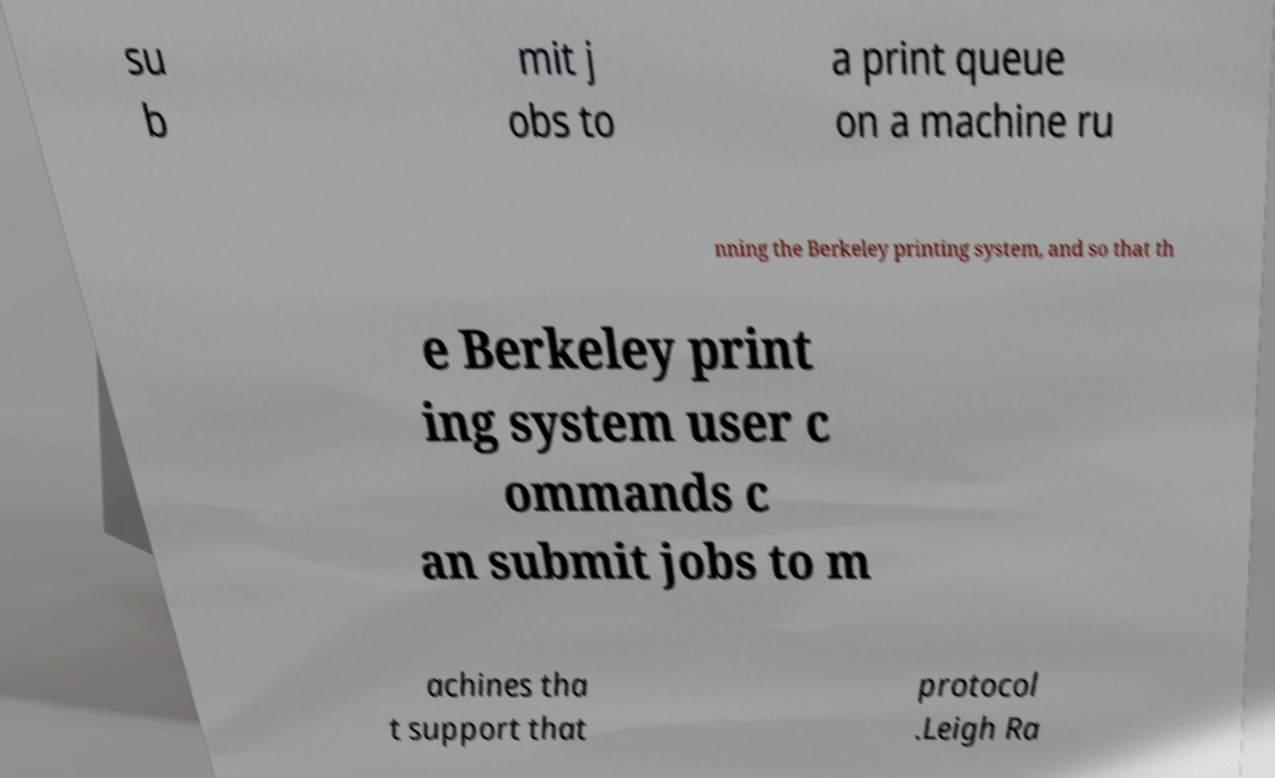Please identify and transcribe the text found in this image. su b mit j obs to a print queue on a machine ru nning the Berkeley printing system, and so that th e Berkeley print ing system user c ommands c an submit jobs to m achines tha t support that protocol .Leigh Ra 